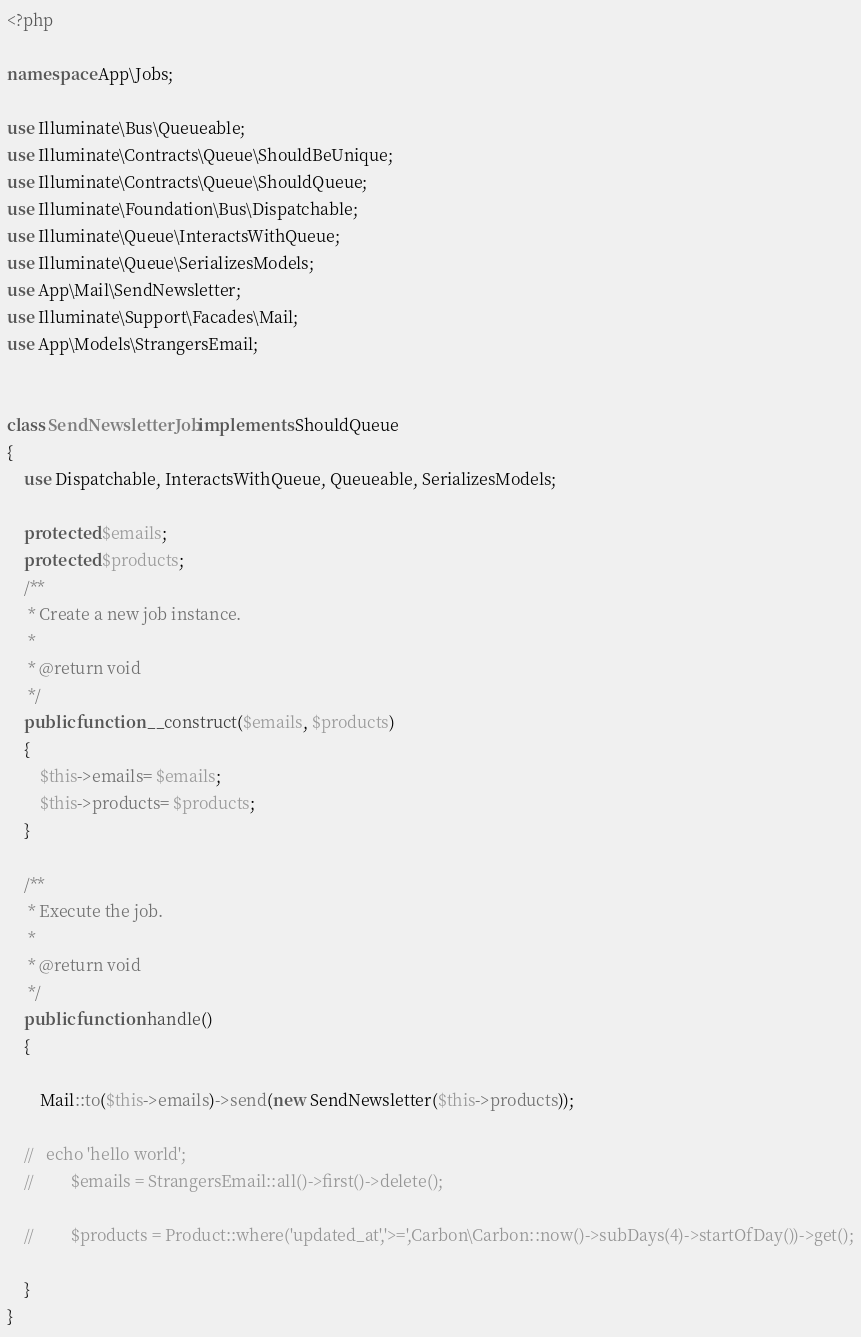<code> <loc_0><loc_0><loc_500><loc_500><_PHP_><?php

namespace App\Jobs;

use Illuminate\Bus\Queueable;
use Illuminate\Contracts\Queue\ShouldBeUnique;
use Illuminate\Contracts\Queue\ShouldQueue;
use Illuminate\Foundation\Bus\Dispatchable;
use Illuminate\Queue\InteractsWithQueue;
use Illuminate\Queue\SerializesModels;
use App\Mail\SendNewsletter;
use Illuminate\Support\Facades\Mail;
use App\Models\StrangersEmail;


class SendNewsletterJob implements ShouldQueue
{
    use Dispatchable, InteractsWithQueue, Queueable, SerializesModels;

    protected $emails;
    protected $products;
    /**
     * Create a new job instance.
     *
     * @return void
     */
    public function __construct($emails, $products)
    {
        $this->emails= $emails;
        $this->products= $products;
    }

    /**
     * Execute the job.
     *
     * @return void
     */
    public function handle()
    {
        
        Mail::to($this->emails)->send(new SendNewsletter($this->products));

    //   echo 'hello world';
    //         $emails = StrangersEmail::all()->first()->delete();

    //         $products = Product::where('updated_at','>=',Carbon\Carbon::now()->subDays(4)->startOfDay())->get();

    }
}
</code> 